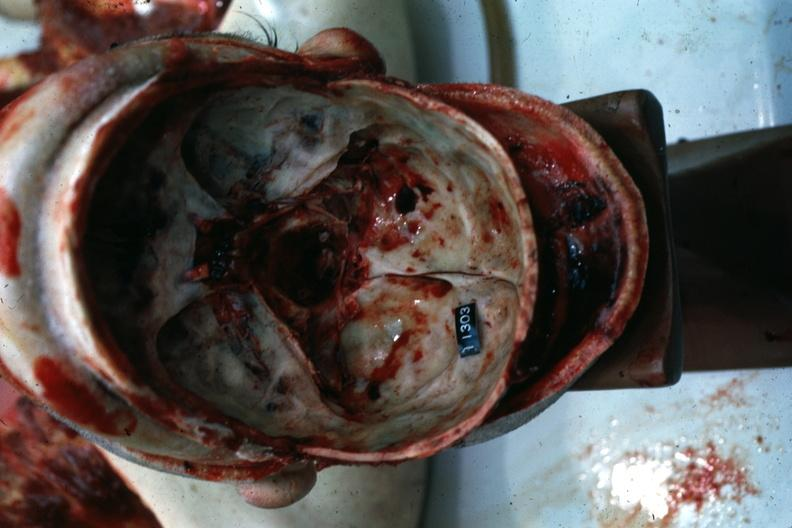s basilar skull fracture present?
Answer the question using a single word or phrase. Yes 